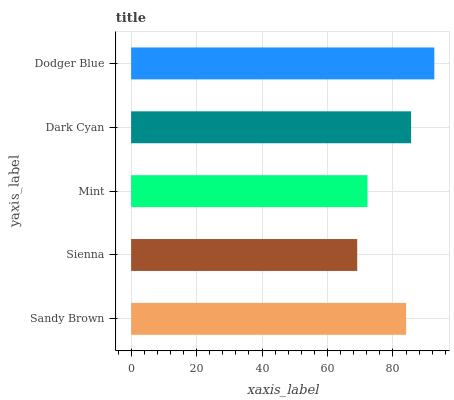Is Sienna the minimum?
Answer yes or no. Yes. Is Dodger Blue the maximum?
Answer yes or no. Yes. Is Mint the minimum?
Answer yes or no. No. Is Mint the maximum?
Answer yes or no. No. Is Mint greater than Sienna?
Answer yes or no. Yes. Is Sienna less than Mint?
Answer yes or no. Yes. Is Sienna greater than Mint?
Answer yes or no. No. Is Mint less than Sienna?
Answer yes or no. No. Is Sandy Brown the high median?
Answer yes or no. Yes. Is Sandy Brown the low median?
Answer yes or no. Yes. Is Mint the high median?
Answer yes or no. No. Is Dodger Blue the low median?
Answer yes or no. No. 